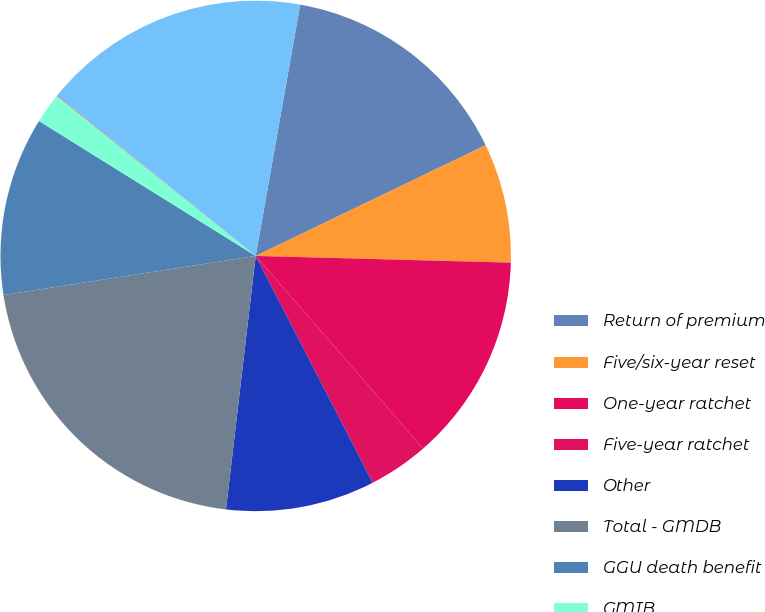Convert chart. <chart><loc_0><loc_0><loc_500><loc_500><pie_chart><fcel>Return of premium<fcel>Five/six-year reset<fcel>One-year ratchet<fcel>Five-year ratchet<fcel>Other<fcel>Total - GMDB<fcel>GGU death benefit<fcel>GMIB<fcel>GMWB<fcel>GMWB for life<nl><fcel>15.07%<fcel>7.56%<fcel>13.19%<fcel>3.81%<fcel>9.44%<fcel>20.7%<fcel>11.31%<fcel>1.93%<fcel>0.05%<fcel>16.95%<nl></chart> 